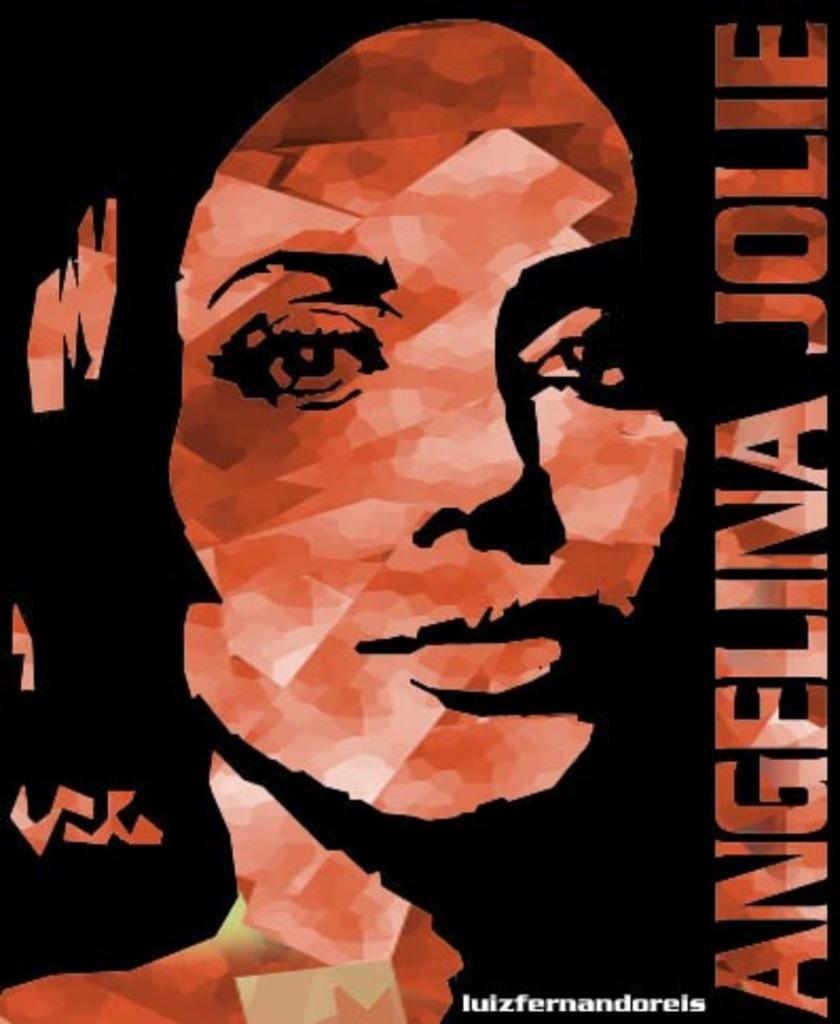In one or two sentences, can you explain what this image depicts? In this image we can see a poster. In the poster we can see the face of a person. On the right side, we can see the text. At the bottom we can see the text. 